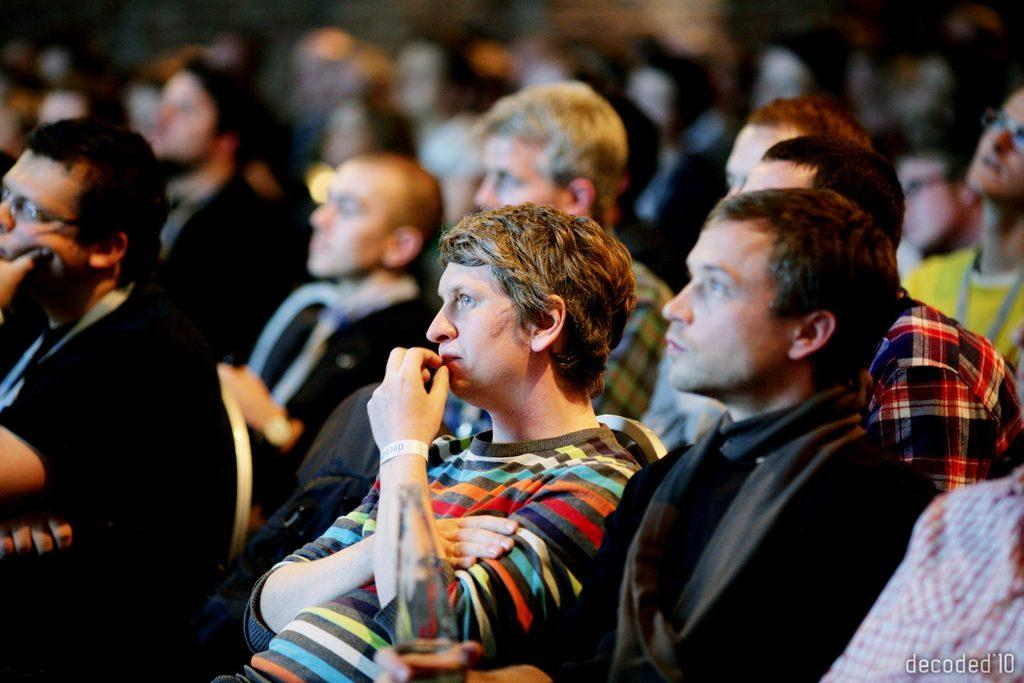How many people are present in the image? There are many people in the image. What are the people doing in the image? The people are sitting in chairs. What type of setting is suggested by the image? It appears to be a conference setting. Can you describe the man in the front of the image? The man in the front is wearing a black dress. What can be said about the background of the image? The background is blurred. What type of earthquake can be seen in the image? There is no earthquake present in the image. What discovery was made by the people in the image? The image does not show any specific discovery being made by the people. 